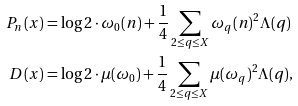Convert formula to latex. <formula><loc_0><loc_0><loc_500><loc_500>P _ { n } ( x ) & = \log 2 \cdot \omega _ { 0 } ( n ) + \frac { 1 } { 4 } \sum _ { 2 \leq q \leq X } \omega _ { q } ( n ) ^ { 2 } \Lambda ( q ) \\ D ( x ) & = \log 2 \cdot \mu ( \omega _ { 0 } ) + \frac { 1 } { 4 } \sum _ { 2 \leq q \leq X } \mu ( \omega _ { q } ) ^ { 2 } \Lambda ( q ) ,</formula> 